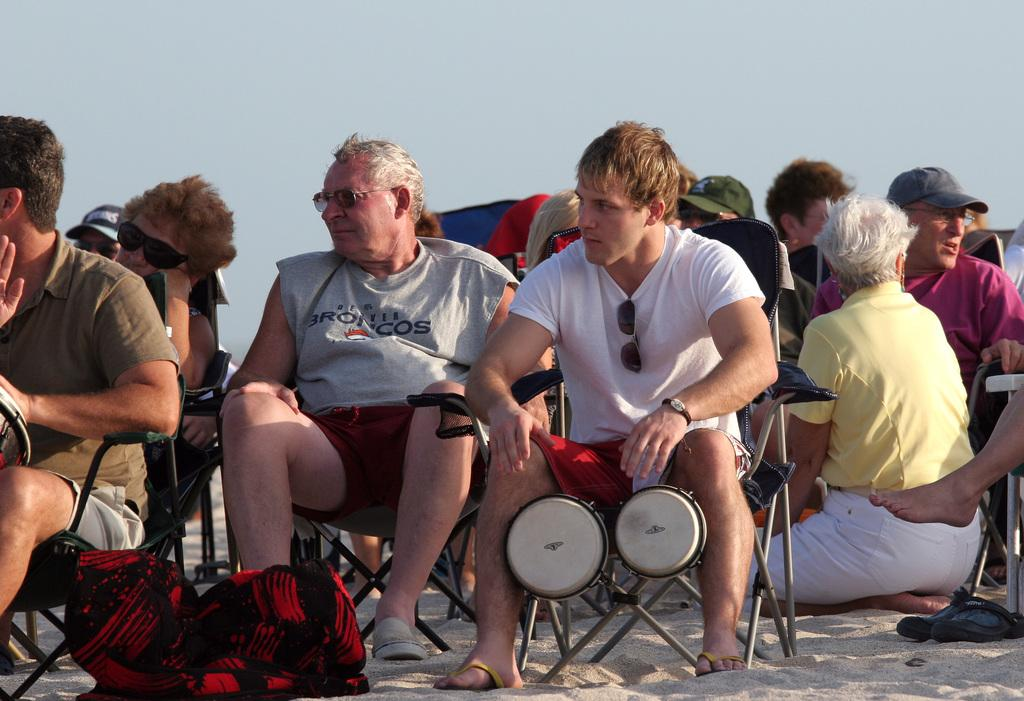What are the people in the image doing? The people in the image are sitting on chairs. What is the surface beneath the chairs? The chairs are on a sandy surface. What is visible at the top of the image? The sky is visible at the top of the image. Can you see any fangs in the image? There are no fangs present in the image. What type of seed is growing on the sandy surface in the image? There is no seed growing on the sandy surface in the image. 